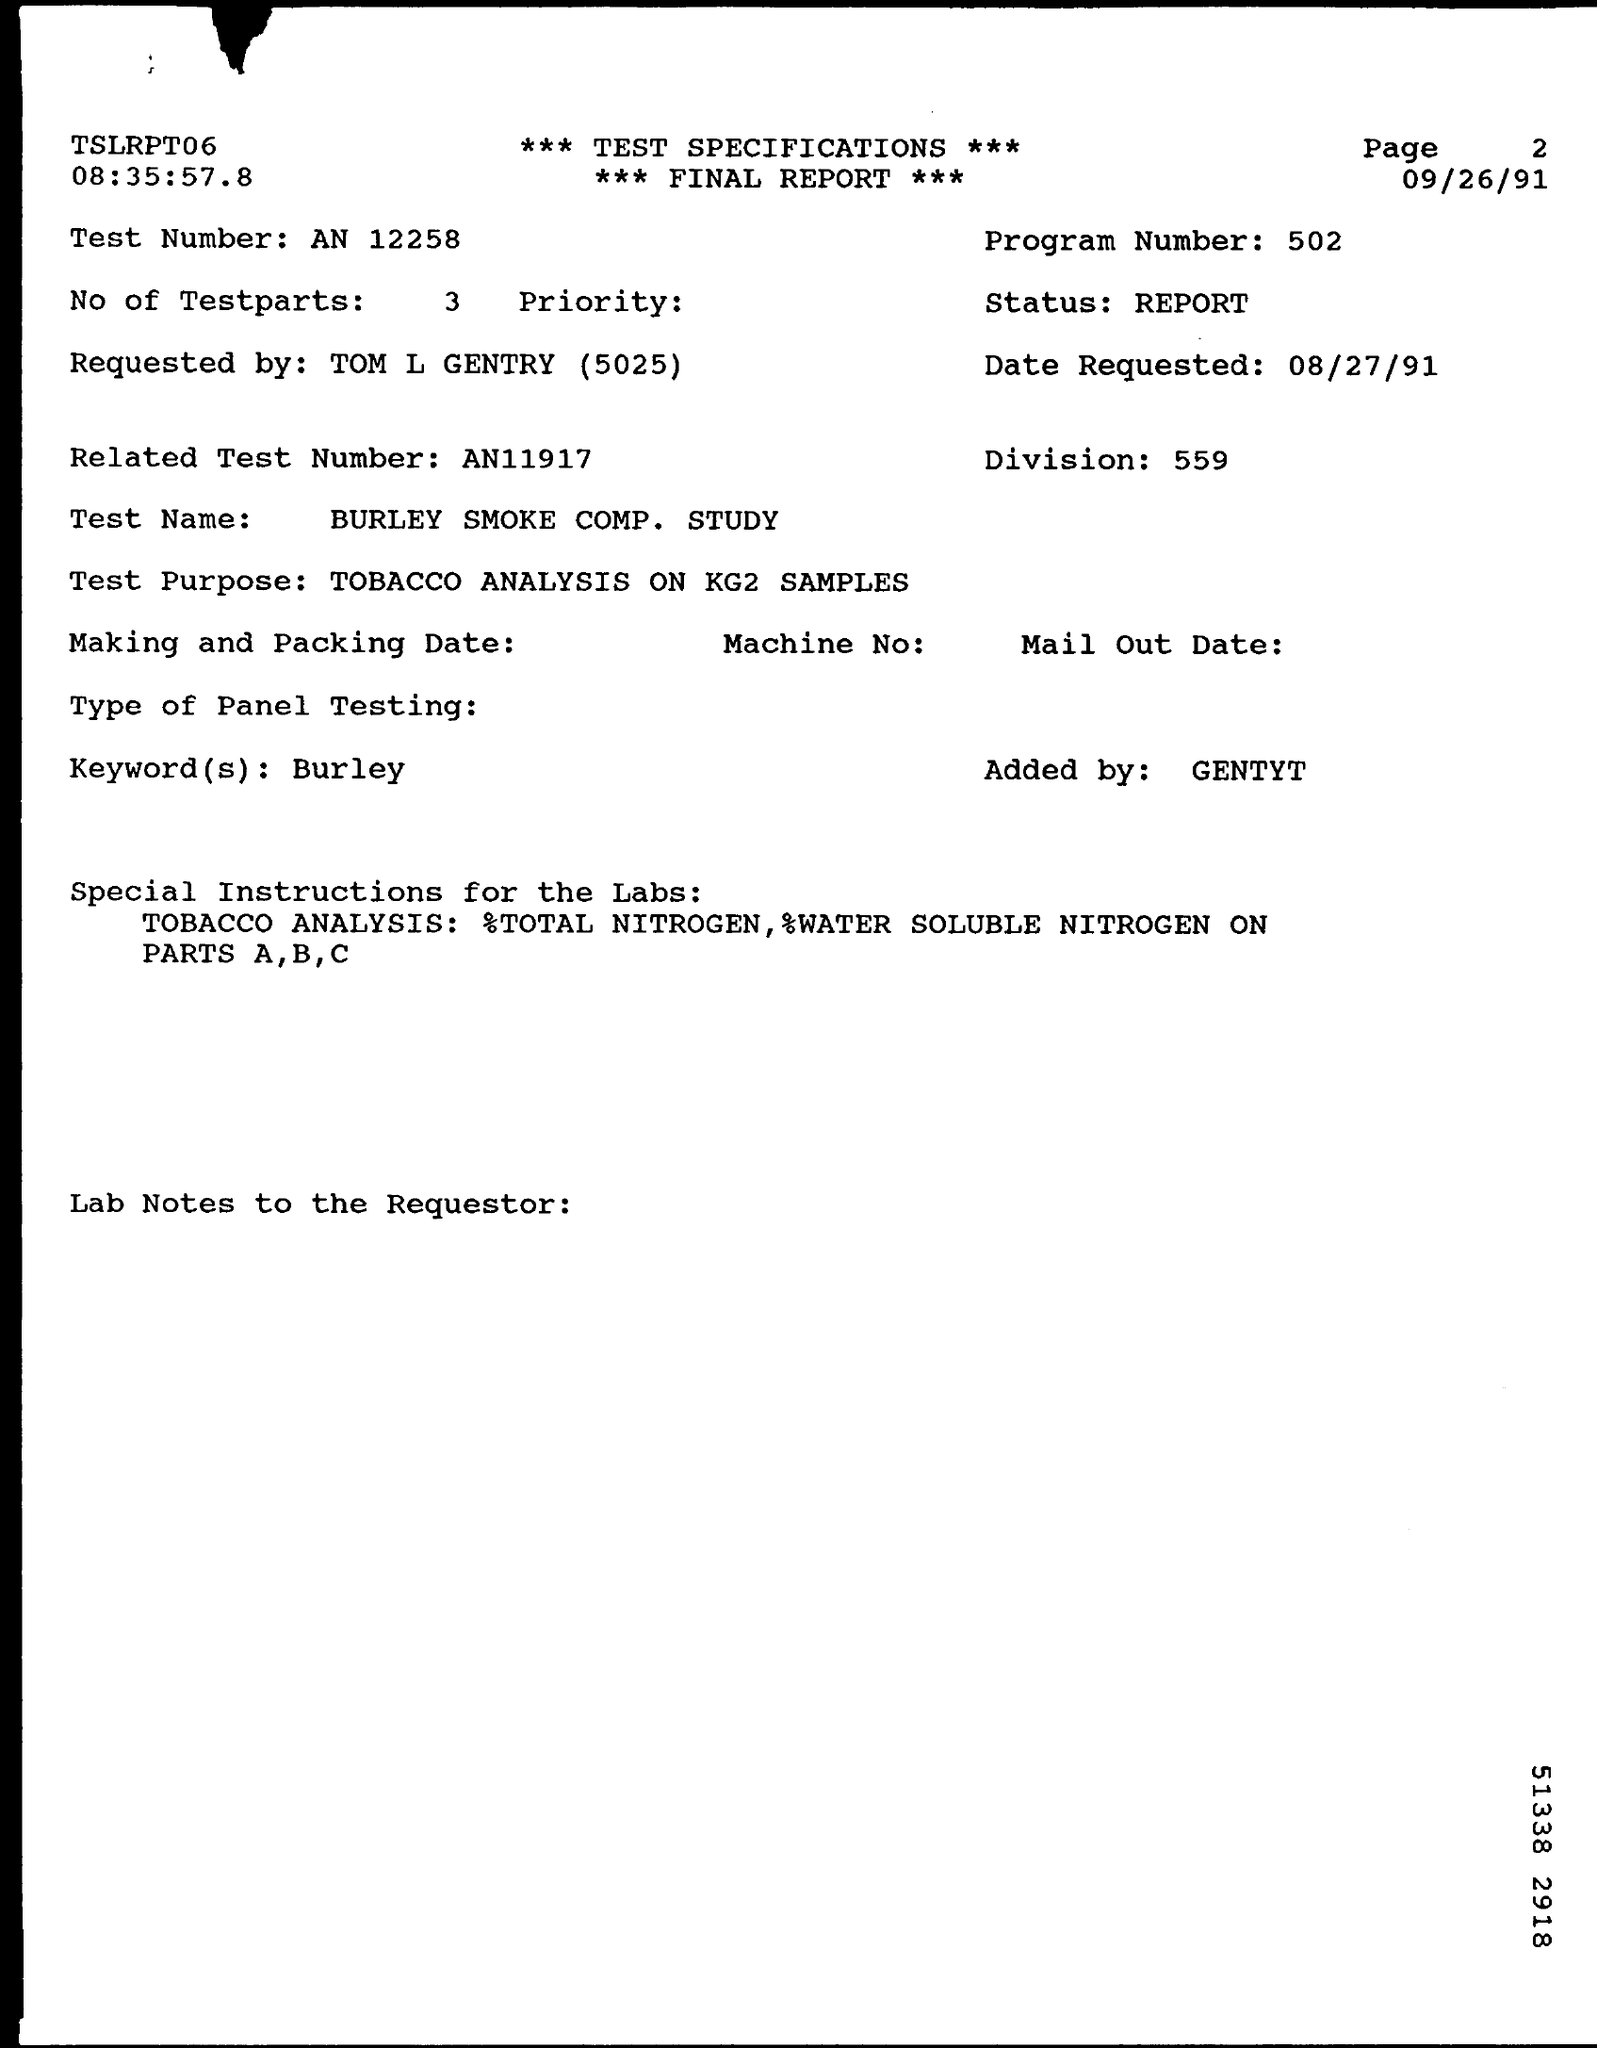List a handful of essential elements in this visual. The program number mentioned in the final report is 502. This final report was requested by Tom L Gentry. The test number mentioned in the final report is 12258. The final report mentioned the keyword "Burley. The division number mentioned in the final report is 559. 